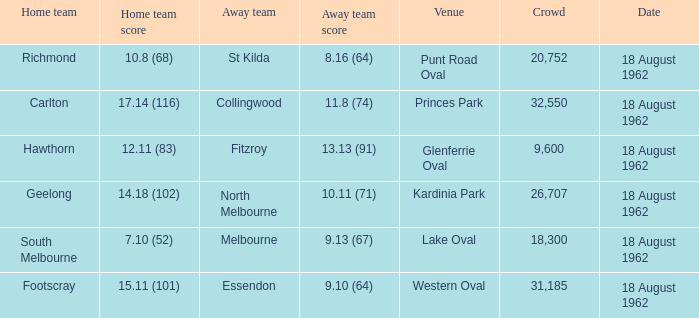What was the home team when the away team scored 9.10 (64)? Footscray. 